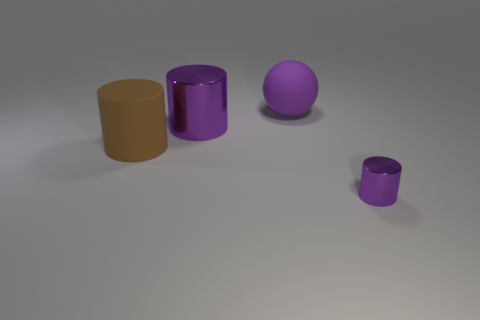How many metallic things are behind the large purple thing on the right side of the large cylinder behind the brown matte thing?
Your answer should be compact. 0. Is the number of large brown cylinders right of the big metallic object less than the number of large brown cylinders?
Offer a terse response. Yes. Are there any other things that have the same shape as the small metallic object?
Your answer should be very brief. Yes. There is a purple metallic object that is behind the small shiny thing; what is its shape?
Your answer should be very brief. Cylinder. What shape is the purple thing behind the metallic object behind the shiny cylinder that is to the right of the matte sphere?
Keep it short and to the point. Sphere. What number of objects are either large matte spheres or purple things?
Offer a terse response. 3. Does the object in front of the brown cylinder have the same shape as the metallic object behind the tiny purple thing?
Your answer should be very brief. Yes. How many metal things are behind the tiny thing and to the right of the large purple matte sphere?
Offer a terse response. 0. What number of other objects are there of the same size as the purple rubber thing?
Provide a short and direct response. 2. What is the cylinder that is in front of the large purple cylinder and to the right of the large brown matte cylinder made of?
Provide a succinct answer. Metal. 